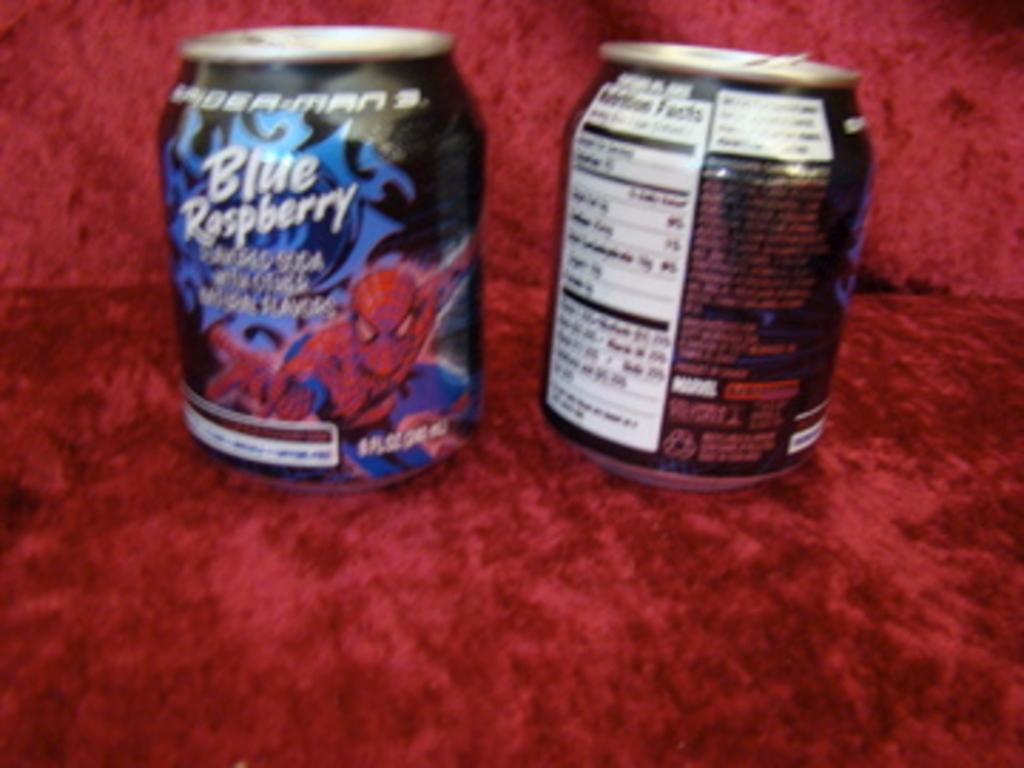<image>
Provide a brief description of the given image. A beverage that's Blue Raspberry flavored features Spider-Man on its packaging. 